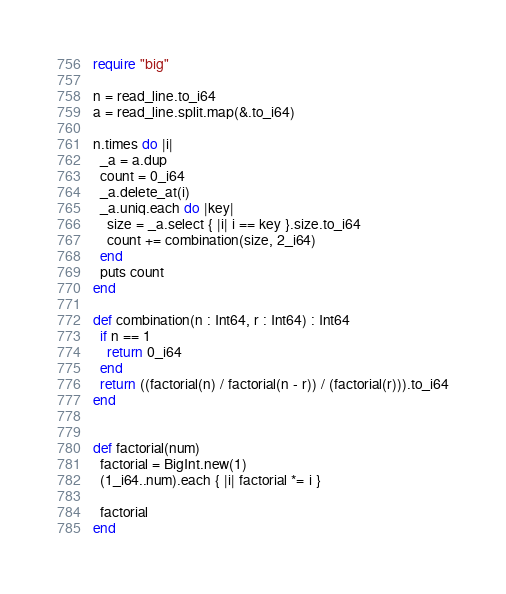<code> <loc_0><loc_0><loc_500><loc_500><_Crystal_>require "big"

n = read_line.to_i64
a = read_line.split.map(&.to_i64)

n.times do |i|
  _a = a.dup
  count = 0_i64
  _a.delete_at(i)
  _a.uniq.each do |key|
    size = _a.select { |i| i == key }.size.to_i64
    count += combination(size, 2_i64)
  end
  puts count
end

def combination(n : Int64, r : Int64) : Int64
  if n == 1
    return 0_i64
  end
  return ((factorial(n) / factorial(n - r)) / (factorial(r))).to_i64
end


def factorial(num)
  factorial = BigInt.new(1)
  (1_i64..num).each { |i| factorial *= i }

  factorial
end
</code> 